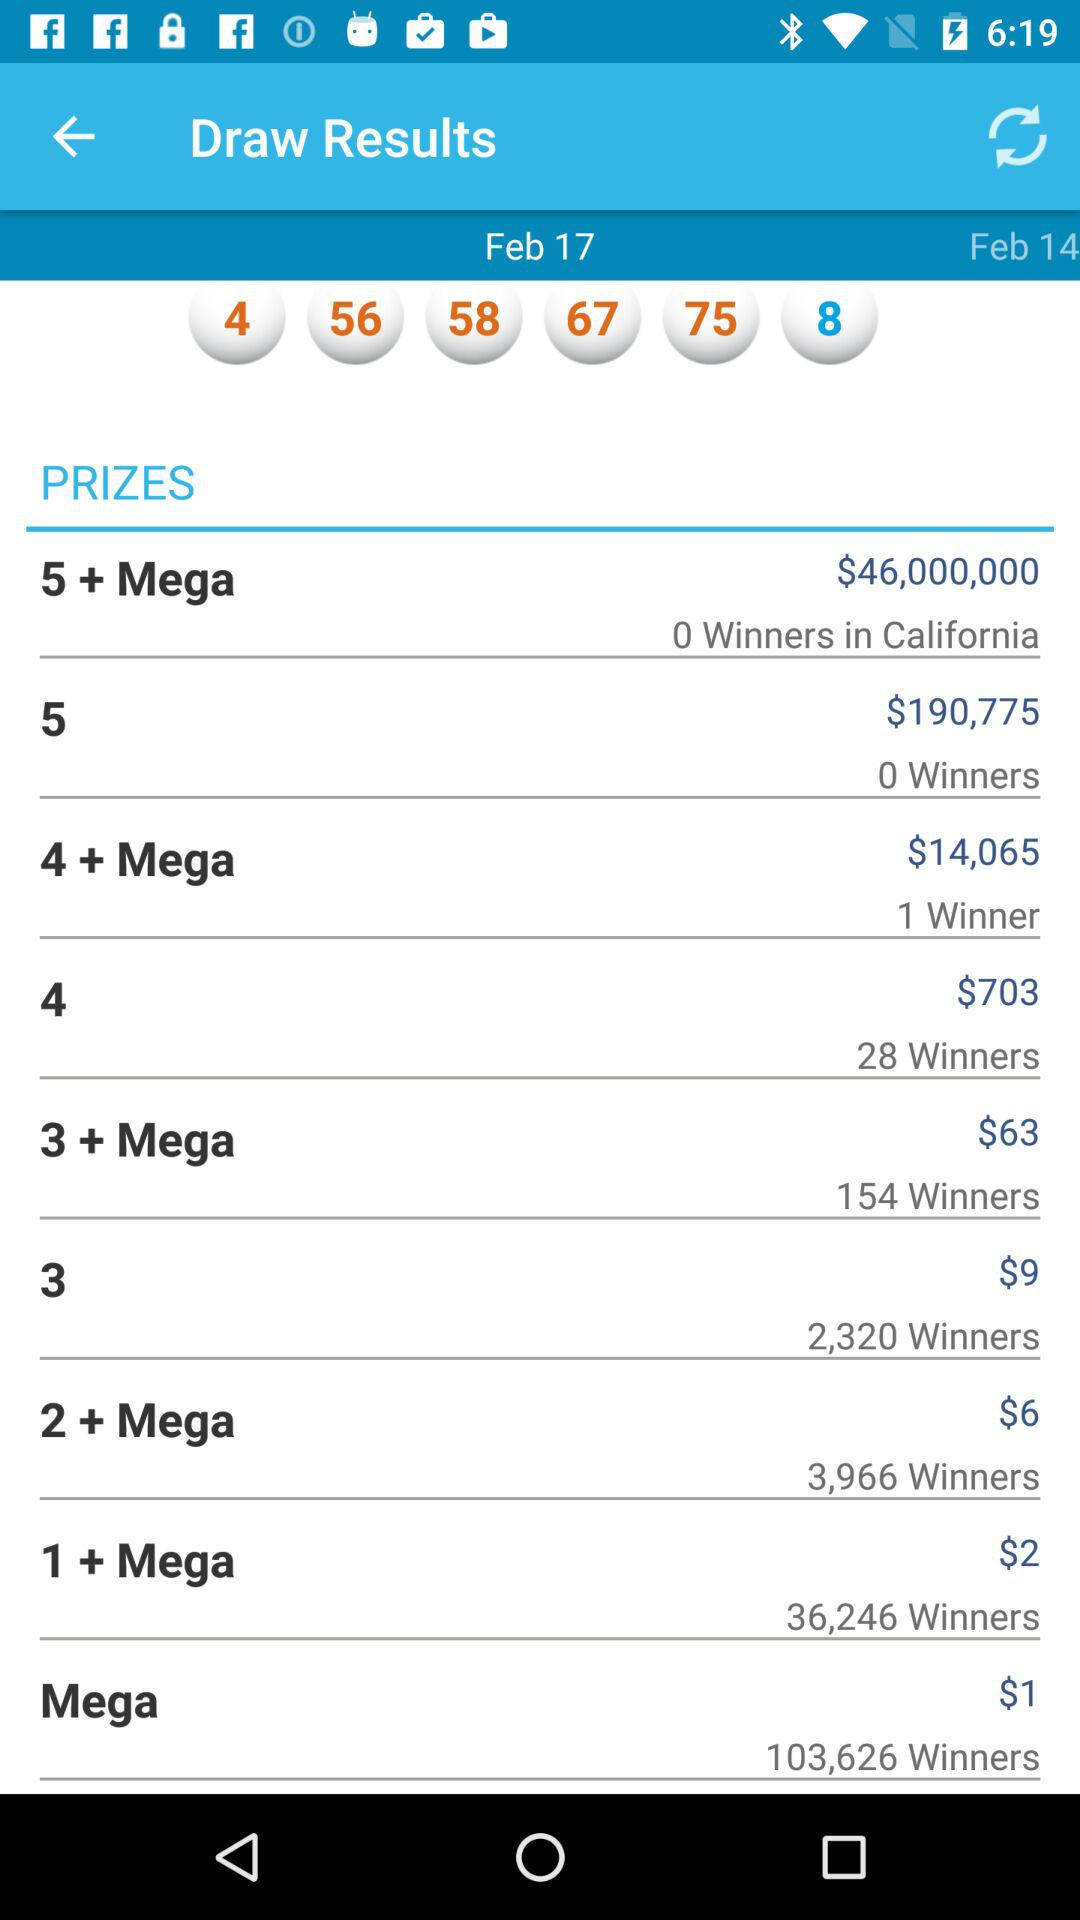How many people have won "3+ Mega" prizes? The number of people who have won "3+ Mega" prizes is 154. 